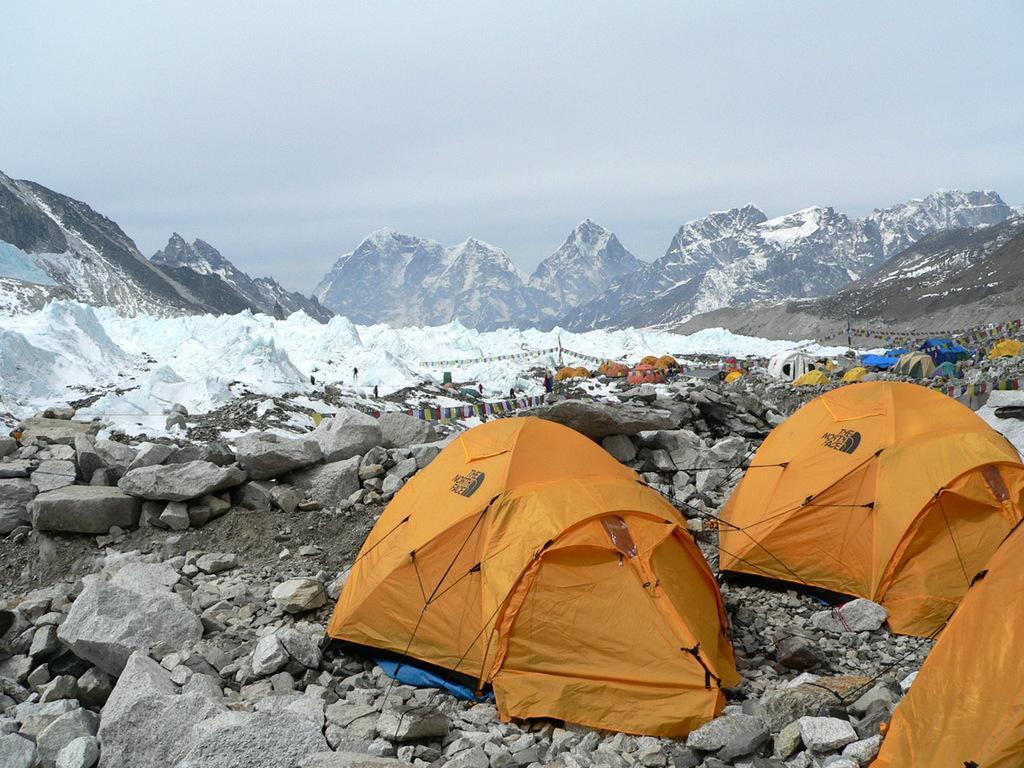Please provide a concise description of this image. In this image we can see snow, mountains, tents, stones and sky. 